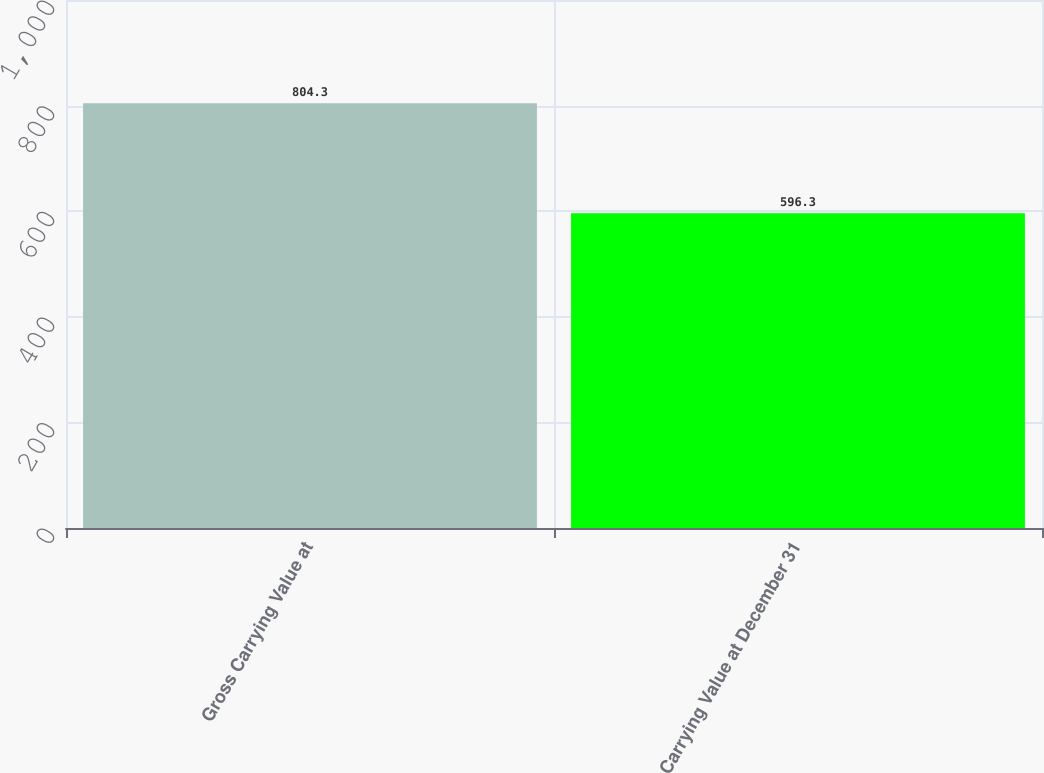Convert chart to OTSL. <chart><loc_0><loc_0><loc_500><loc_500><bar_chart><fcel>Gross Carrying Value at<fcel>Carrying Value at December 31<nl><fcel>804.3<fcel>596.3<nl></chart> 